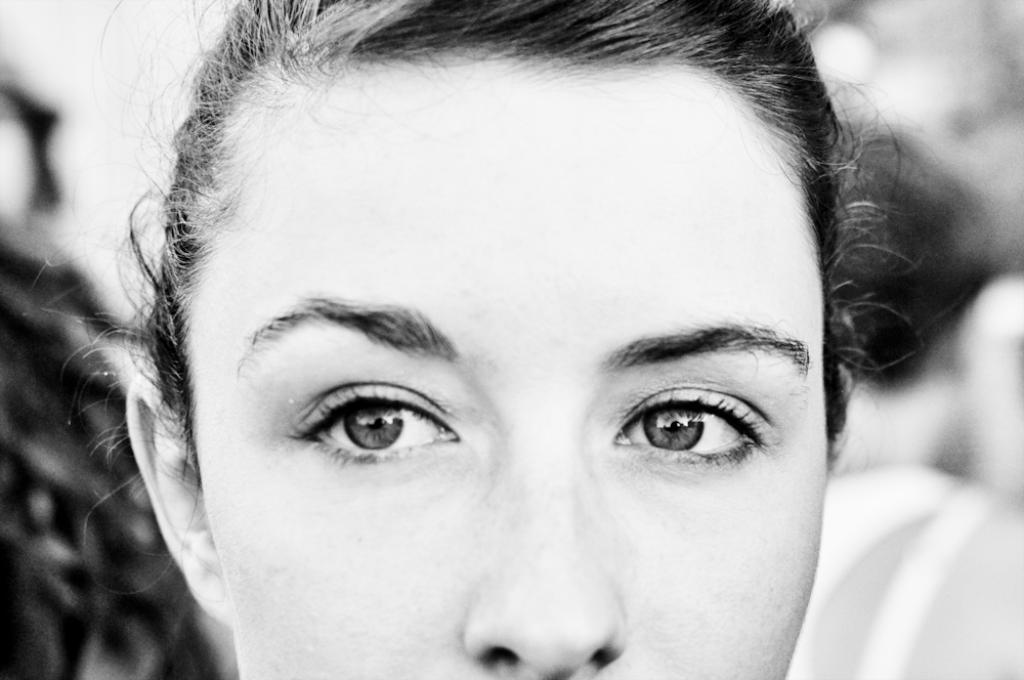Who is the main subject in the image? There is a woman in the image. What facial features can be seen on the woman? The woman has two eyes and a nose. What else can be seen in the image besides the woman? There are other objects in the background of the image. What type of vacation is the woman planning based on the image? There is no information about a vacation or any related plans in the image. 